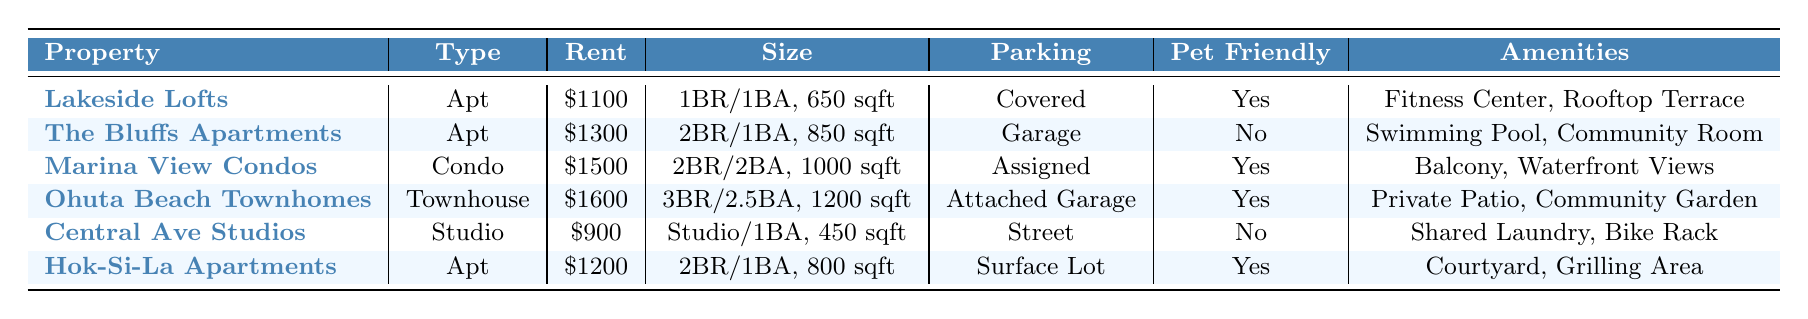What is the monthly rent of Lakeside Lofts? According to the table, the monthly rent listed for Lakeside Lofts is $1100.
Answer: $1100 Which property has the highest number of bedrooms? By comparing the number of bedrooms for each listed property, Ohuta Beach Townhomes has 3 bedrooms, which is more than any other property.
Answer: Ohuta Beach Townhomes Is Marina View Condos pet-friendly? The table indicates that Marina View Condos is pet-friendly, as it lists "Yes" under the pet-friendly column.
Answer: Yes What is the distance to downtown for Central Ave Studios? The table shows that Central Ave Studios has a distance of 0.1 miles to downtown.
Answer: 0.1 miles What is the total rent of the properties with 2 bedrooms? The rents for properties with 2 bedrooms are $1300 (The Bluffs Apartments), $1500 (Marina View Condos), and $1200 (Hok-Si-La Apartments). Summing these gives $1300 + $1500 + $1200 = $4000.
Answer: $4000 How many properties have laundry in the unit? By analyzing the laundry_in_unit column, Lakeside Lofts, The Bluffs Apartments, Marina View Condos, Ohuta Beach Townhomes, and Hok-Si-La Apartments all indicate laundry in the unit, totaling 5 properties.
Answer: 5 Which property is the least expensive and what is the monthly rent? Central Ave Studios is listed as the least expensive property with a rent of $900.
Answer: Central Ave Studios, $900 What is the average size of the apartments listed in square feet? The sizes of the apartments are 650, 850, 800, and 450 square feet. The average size is (650 + 850 + 800 + 450) / 4 = 687.5 square feet.
Answer: 687.5 square feet Are there any properties with both a balcony and being pet-friendly? Only Marina View Condos has a balcony and is marked as pet-friendly, according to the amenities listed.
Answer: Yes Which property has the most amenities? Ohuta Beach Townhomes has three amenities: Private Patio, Community Garden, and Playground, which is more than the others listed.
Answer: Ohuta Beach Townhomes 